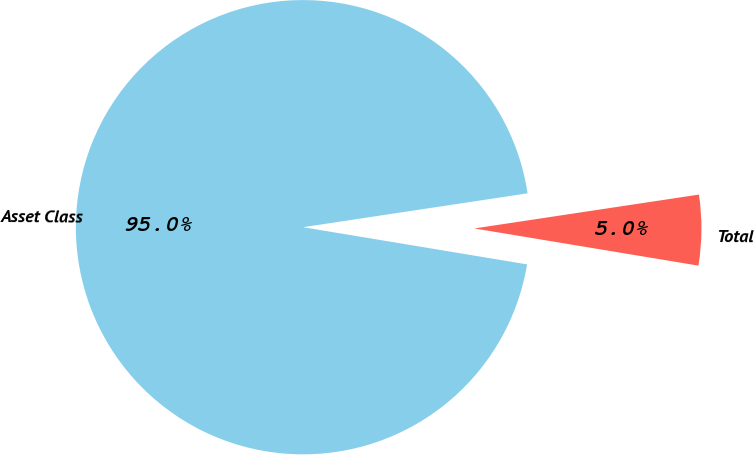<chart> <loc_0><loc_0><loc_500><loc_500><pie_chart><fcel>Asset Class<fcel>Total<nl><fcel>95.0%<fcel>5.0%<nl></chart> 